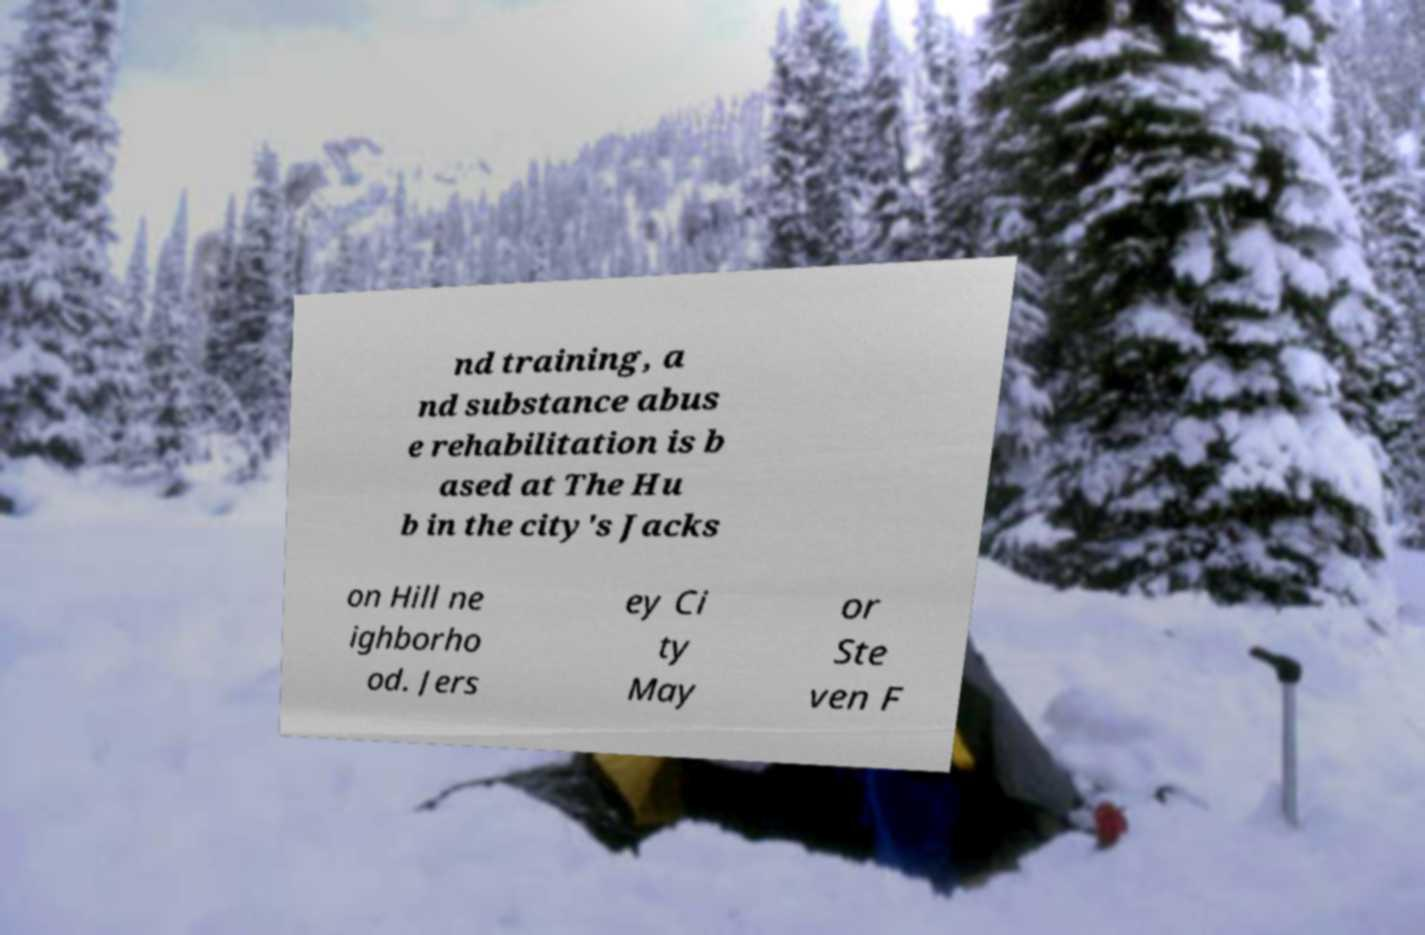There's text embedded in this image that I need extracted. Can you transcribe it verbatim? nd training, a nd substance abus e rehabilitation is b ased at The Hu b in the city's Jacks on Hill ne ighborho od. Jers ey Ci ty May or Ste ven F 